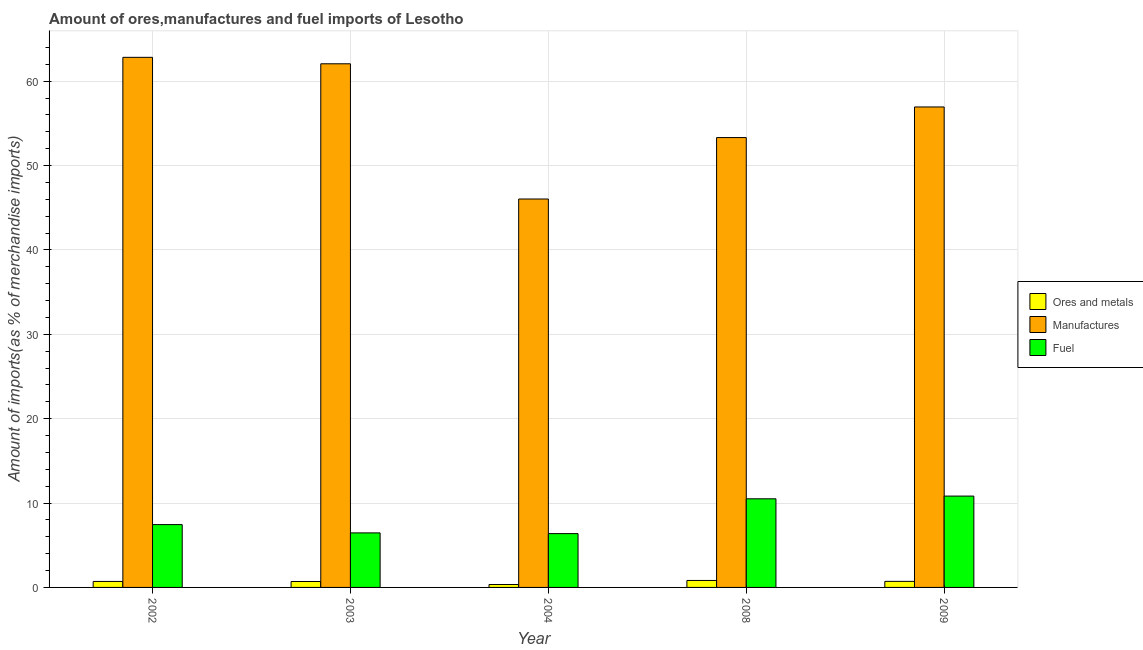How many groups of bars are there?
Provide a succinct answer. 5. Are the number of bars per tick equal to the number of legend labels?
Provide a short and direct response. Yes. Are the number of bars on each tick of the X-axis equal?
Offer a very short reply. Yes. How many bars are there on the 3rd tick from the right?
Provide a succinct answer. 3. What is the percentage of manufactures imports in 2008?
Give a very brief answer. 53.31. Across all years, what is the maximum percentage of manufactures imports?
Your response must be concise. 62.82. Across all years, what is the minimum percentage of ores and metals imports?
Give a very brief answer. 0.34. In which year was the percentage of manufactures imports maximum?
Offer a very short reply. 2002. In which year was the percentage of ores and metals imports minimum?
Provide a short and direct response. 2004. What is the total percentage of fuel imports in the graph?
Provide a short and direct response. 41.61. What is the difference between the percentage of fuel imports in 2003 and that in 2009?
Your answer should be compact. -4.36. What is the difference between the percentage of fuel imports in 2003 and the percentage of ores and metals imports in 2008?
Provide a succinct answer. -4.04. What is the average percentage of manufactures imports per year?
Offer a very short reply. 56.23. In the year 2003, what is the difference between the percentage of manufactures imports and percentage of fuel imports?
Offer a terse response. 0. In how many years, is the percentage of manufactures imports greater than 20 %?
Offer a very short reply. 5. What is the ratio of the percentage of manufactures imports in 2003 to that in 2008?
Offer a terse response. 1.16. Is the percentage of fuel imports in 2004 less than that in 2009?
Your answer should be compact. Yes. Is the difference between the percentage of ores and metals imports in 2002 and 2004 greater than the difference between the percentage of manufactures imports in 2002 and 2004?
Ensure brevity in your answer.  No. What is the difference between the highest and the second highest percentage of ores and metals imports?
Provide a short and direct response. 0.11. What is the difference between the highest and the lowest percentage of manufactures imports?
Your answer should be very brief. 16.79. Is the sum of the percentage of fuel imports in 2003 and 2008 greater than the maximum percentage of ores and metals imports across all years?
Your answer should be compact. Yes. What does the 1st bar from the left in 2008 represents?
Your answer should be compact. Ores and metals. What does the 1st bar from the right in 2004 represents?
Offer a very short reply. Fuel. Is it the case that in every year, the sum of the percentage of ores and metals imports and percentage of manufactures imports is greater than the percentage of fuel imports?
Give a very brief answer. Yes. How many bars are there?
Ensure brevity in your answer.  15. Are all the bars in the graph horizontal?
Give a very brief answer. No. Does the graph contain any zero values?
Give a very brief answer. No. Does the graph contain grids?
Your response must be concise. Yes. What is the title of the graph?
Provide a short and direct response. Amount of ores,manufactures and fuel imports of Lesotho. What is the label or title of the Y-axis?
Offer a terse response. Amount of imports(as % of merchandise imports). What is the Amount of imports(as % of merchandise imports) in Ores and metals in 2002?
Offer a terse response. 0.71. What is the Amount of imports(as % of merchandise imports) in Manufactures in 2002?
Your answer should be compact. 62.82. What is the Amount of imports(as % of merchandise imports) of Fuel in 2002?
Offer a very short reply. 7.45. What is the Amount of imports(as % of merchandise imports) of Ores and metals in 2003?
Keep it short and to the point. 0.7. What is the Amount of imports(as % of merchandise imports) in Manufactures in 2003?
Ensure brevity in your answer.  62.06. What is the Amount of imports(as % of merchandise imports) in Fuel in 2003?
Keep it short and to the point. 6.46. What is the Amount of imports(as % of merchandise imports) of Ores and metals in 2004?
Give a very brief answer. 0.34. What is the Amount of imports(as % of merchandise imports) of Manufactures in 2004?
Provide a short and direct response. 46.03. What is the Amount of imports(as % of merchandise imports) in Fuel in 2004?
Offer a terse response. 6.38. What is the Amount of imports(as % of merchandise imports) in Ores and metals in 2008?
Ensure brevity in your answer.  0.83. What is the Amount of imports(as % of merchandise imports) of Manufactures in 2008?
Keep it short and to the point. 53.31. What is the Amount of imports(as % of merchandise imports) in Fuel in 2008?
Your response must be concise. 10.5. What is the Amount of imports(as % of merchandise imports) of Ores and metals in 2009?
Offer a very short reply. 0.72. What is the Amount of imports(as % of merchandise imports) in Manufactures in 2009?
Give a very brief answer. 56.94. What is the Amount of imports(as % of merchandise imports) of Fuel in 2009?
Provide a succinct answer. 10.83. Across all years, what is the maximum Amount of imports(as % of merchandise imports) of Ores and metals?
Your answer should be very brief. 0.83. Across all years, what is the maximum Amount of imports(as % of merchandise imports) of Manufactures?
Make the answer very short. 62.82. Across all years, what is the maximum Amount of imports(as % of merchandise imports) of Fuel?
Keep it short and to the point. 10.83. Across all years, what is the minimum Amount of imports(as % of merchandise imports) of Ores and metals?
Offer a very short reply. 0.34. Across all years, what is the minimum Amount of imports(as % of merchandise imports) in Manufactures?
Keep it short and to the point. 46.03. Across all years, what is the minimum Amount of imports(as % of merchandise imports) of Fuel?
Your answer should be compact. 6.38. What is the total Amount of imports(as % of merchandise imports) of Ores and metals in the graph?
Provide a short and direct response. 3.3. What is the total Amount of imports(as % of merchandise imports) in Manufactures in the graph?
Your answer should be compact. 281.16. What is the total Amount of imports(as % of merchandise imports) of Fuel in the graph?
Your answer should be compact. 41.61. What is the difference between the Amount of imports(as % of merchandise imports) of Ores and metals in 2002 and that in 2003?
Keep it short and to the point. 0.01. What is the difference between the Amount of imports(as % of merchandise imports) in Manufactures in 2002 and that in 2003?
Your answer should be compact. 0.77. What is the difference between the Amount of imports(as % of merchandise imports) in Fuel in 2002 and that in 2003?
Your answer should be compact. 0.98. What is the difference between the Amount of imports(as % of merchandise imports) in Ores and metals in 2002 and that in 2004?
Keep it short and to the point. 0.36. What is the difference between the Amount of imports(as % of merchandise imports) of Manufactures in 2002 and that in 2004?
Keep it short and to the point. 16.79. What is the difference between the Amount of imports(as % of merchandise imports) of Fuel in 2002 and that in 2004?
Ensure brevity in your answer.  1.07. What is the difference between the Amount of imports(as % of merchandise imports) of Ores and metals in 2002 and that in 2008?
Keep it short and to the point. -0.12. What is the difference between the Amount of imports(as % of merchandise imports) in Manufactures in 2002 and that in 2008?
Your response must be concise. 9.51. What is the difference between the Amount of imports(as % of merchandise imports) in Fuel in 2002 and that in 2008?
Keep it short and to the point. -3.06. What is the difference between the Amount of imports(as % of merchandise imports) of Ores and metals in 2002 and that in 2009?
Your answer should be very brief. -0.01. What is the difference between the Amount of imports(as % of merchandise imports) in Manufactures in 2002 and that in 2009?
Keep it short and to the point. 5.88. What is the difference between the Amount of imports(as % of merchandise imports) of Fuel in 2002 and that in 2009?
Provide a short and direct response. -3.38. What is the difference between the Amount of imports(as % of merchandise imports) of Ores and metals in 2003 and that in 2004?
Give a very brief answer. 0.36. What is the difference between the Amount of imports(as % of merchandise imports) in Manufactures in 2003 and that in 2004?
Your answer should be compact. 16.02. What is the difference between the Amount of imports(as % of merchandise imports) in Fuel in 2003 and that in 2004?
Make the answer very short. 0.09. What is the difference between the Amount of imports(as % of merchandise imports) in Ores and metals in 2003 and that in 2008?
Your answer should be compact. -0.12. What is the difference between the Amount of imports(as % of merchandise imports) in Manufactures in 2003 and that in 2008?
Ensure brevity in your answer.  8.74. What is the difference between the Amount of imports(as % of merchandise imports) of Fuel in 2003 and that in 2008?
Keep it short and to the point. -4.04. What is the difference between the Amount of imports(as % of merchandise imports) of Ores and metals in 2003 and that in 2009?
Your answer should be very brief. -0.02. What is the difference between the Amount of imports(as % of merchandise imports) of Manufactures in 2003 and that in 2009?
Give a very brief answer. 5.12. What is the difference between the Amount of imports(as % of merchandise imports) of Fuel in 2003 and that in 2009?
Provide a short and direct response. -4.36. What is the difference between the Amount of imports(as % of merchandise imports) in Ores and metals in 2004 and that in 2008?
Keep it short and to the point. -0.48. What is the difference between the Amount of imports(as % of merchandise imports) of Manufactures in 2004 and that in 2008?
Ensure brevity in your answer.  -7.28. What is the difference between the Amount of imports(as % of merchandise imports) of Fuel in 2004 and that in 2008?
Provide a succinct answer. -4.13. What is the difference between the Amount of imports(as % of merchandise imports) in Ores and metals in 2004 and that in 2009?
Provide a short and direct response. -0.37. What is the difference between the Amount of imports(as % of merchandise imports) in Manufactures in 2004 and that in 2009?
Provide a short and direct response. -10.91. What is the difference between the Amount of imports(as % of merchandise imports) in Fuel in 2004 and that in 2009?
Your response must be concise. -4.45. What is the difference between the Amount of imports(as % of merchandise imports) of Ores and metals in 2008 and that in 2009?
Make the answer very short. 0.11. What is the difference between the Amount of imports(as % of merchandise imports) of Manufactures in 2008 and that in 2009?
Your answer should be very brief. -3.63. What is the difference between the Amount of imports(as % of merchandise imports) of Fuel in 2008 and that in 2009?
Offer a terse response. -0.32. What is the difference between the Amount of imports(as % of merchandise imports) in Ores and metals in 2002 and the Amount of imports(as % of merchandise imports) in Manufactures in 2003?
Ensure brevity in your answer.  -61.35. What is the difference between the Amount of imports(as % of merchandise imports) of Ores and metals in 2002 and the Amount of imports(as % of merchandise imports) of Fuel in 2003?
Provide a short and direct response. -5.75. What is the difference between the Amount of imports(as % of merchandise imports) in Manufactures in 2002 and the Amount of imports(as % of merchandise imports) in Fuel in 2003?
Offer a terse response. 56.36. What is the difference between the Amount of imports(as % of merchandise imports) in Ores and metals in 2002 and the Amount of imports(as % of merchandise imports) in Manufactures in 2004?
Make the answer very short. -45.32. What is the difference between the Amount of imports(as % of merchandise imports) in Ores and metals in 2002 and the Amount of imports(as % of merchandise imports) in Fuel in 2004?
Ensure brevity in your answer.  -5.67. What is the difference between the Amount of imports(as % of merchandise imports) of Manufactures in 2002 and the Amount of imports(as % of merchandise imports) of Fuel in 2004?
Your response must be concise. 56.45. What is the difference between the Amount of imports(as % of merchandise imports) in Ores and metals in 2002 and the Amount of imports(as % of merchandise imports) in Manufactures in 2008?
Make the answer very short. -52.6. What is the difference between the Amount of imports(as % of merchandise imports) in Ores and metals in 2002 and the Amount of imports(as % of merchandise imports) in Fuel in 2008?
Give a very brief answer. -9.79. What is the difference between the Amount of imports(as % of merchandise imports) in Manufactures in 2002 and the Amount of imports(as % of merchandise imports) in Fuel in 2008?
Keep it short and to the point. 52.32. What is the difference between the Amount of imports(as % of merchandise imports) of Ores and metals in 2002 and the Amount of imports(as % of merchandise imports) of Manufactures in 2009?
Offer a very short reply. -56.23. What is the difference between the Amount of imports(as % of merchandise imports) of Ores and metals in 2002 and the Amount of imports(as % of merchandise imports) of Fuel in 2009?
Make the answer very short. -10.12. What is the difference between the Amount of imports(as % of merchandise imports) of Manufactures in 2002 and the Amount of imports(as % of merchandise imports) of Fuel in 2009?
Ensure brevity in your answer.  52. What is the difference between the Amount of imports(as % of merchandise imports) in Ores and metals in 2003 and the Amount of imports(as % of merchandise imports) in Manufactures in 2004?
Offer a very short reply. -45.33. What is the difference between the Amount of imports(as % of merchandise imports) in Ores and metals in 2003 and the Amount of imports(as % of merchandise imports) in Fuel in 2004?
Your response must be concise. -5.67. What is the difference between the Amount of imports(as % of merchandise imports) of Manufactures in 2003 and the Amount of imports(as % of merchandise imports) of Fuel in 2004?
Offer a very short reply. 55.68. What is the difference between the Amount of imports(as % of merchandise imports) of Ores and metals in 2003 and the Amount of imports(as % of merchandise imports) of Manufactures in 2008?
Offer a very short reply. -52.61. What is the difference between the Amount of imports(as % of merchandise imports) of Manufactures in 2003 and the Amount of imports(as % of merchandise imports) of Fuel in 2008?
Your answer should be compact. 51.55. What is the difference between the Amount of imports(as % of merchandise imports) in Ores and metals in 2003 and the Amount of imports(as % of merchandise imports) in Manufactures in 2009?
Provide a short and direct response. -56.24. What is the difference between the Amount of imports(as % of merchandise imports) in Ores and metals in 2003 and the Amount of imports(as % of merchandise imports) in Fuel in 2009?
Your response must be concise. -10.12. What is the difference between the Amount of imports(as % of merchandise imports) in Manufactures in 2003 and the Amount of imports(as % of merchandise imports) in Fuel in 2009?
Your answer should be compact. 51.23. What is the difference between the Amount of imports(as % of merchandise imports) of Ores and metals in 2004 and the Amount of imports(as % of merchandise imports) of Manufactures in 2008?
Your answer should be very brief. -52.97. What is the difference between the Amount of imports(as % of merchandise imports) of Ores and metals in 2004 and the Amount of imports(as % of merchandise imports) of Fuel in 2008?
Provide a short and direct response. -10.16. What is the difference between the Amount of imports(as % of merchandise imports) of Manufactures in 2004 and the Amount of imports(as % of merchandise imports) of Fuel in 2008?
Give a very brief answer. 35.53. What is the difference between the Amount of imports(as % of merchandise imports) of Ores and metals in 2004 and the Amount of imports(as % of merchandise imports) of Manufactures in 2009?
Your answer should be compact. -56.6. What is the difference between the Amount of imports(as % of merchandise imports) in Ores and metals in 2004 and the Amount of imports(as % of merchandise imports) in Fuel in 2009?
Your answer should be compact. -10.48. What is the difference between the Amount of imports(as % of merchandise imports) in Manufactures in 2004 and the Amount of imports(as % of merchandise imports) in Fuel in 2009?
Provide a succinct answer. 35.21. What is the difference between the Amount of imports(as % of merchandise imports) in Ores and metals in 2008 and the Amount of imports(as % of merchandise imports) in Manufactures in 2009?
Offer a terse response. -56.11. What is the difference between the Amount of imports(as % of merchandise imports) in Ores and metals in 2008 and the Amount of imports(as % of merchandise imports) in Fuel in 2009?
Offer a very short reply. -10. What is the difference between the Amount of imports(as % of merchandise imports) of Manufactures in 2008 and the Amount of imports(as % of merchandise imports) of Fuel in 2009?
Make the answer very short. 42.49. What is the average Amount of imports(as % of merchandise imports) of Ores and metals per year?
Your answer should be very brief. 0.66. What is the average Amount of imports(as % of merchandise imports) of Manufactures per year?
Give a very brief answer. 56.23. What is the average Amount of imports(as % of merchandise imports) in Fuel per year?
Offer a very short reply. 8.32. In the year 2002, what is the difference between the Amount of imports(as % of merchandise imports) in Ores and metals and Amount of imports(as % of merchandise imports) in Manufactures?
Make the answer very short. -62.11. In the year 2002, what is the difference between the Amount of imports(as % of merchandise imports) in Ores and metals and Amount of imports(as % of merchandise imports) in Fuel?
Provide a succinct answer. -6.74. In the year 2002, what is the difference between the Amount of imports(as % of merchandise imports) in Manufactures and Amount of imports(as % of merchandise imports) in Fuel?
Provide a succinct answer. 55.38. In the year 2003, what is the difference between the Amount of imports(as % of merchandise imports) in Ores and metals and Amount of imports(as % of merchandise imports) in Manufactures?
Offer a very short reply. -61.35. In the year 2003, what is the difference between the Amount of imports(as % of merchandise imports) of Ores and metals and Amount of imports(as % of merchandise imports) of Fuel?
Give a very brief answer. -5.76. In the year 2003, what is the difference between the Amount of imports(as % of merchandise imports) of Manufactures and Amount of imports(as % of merchandise imports) of Fuel?
Make the answer very short. 55.59. In the year 2004, what is the difference between the Amount of imports(as % of merchandise imports) of Ores and metals and Amount of imports(as % of merchandise imports) of Manufactures?
Offer a terse response. -45.69. In the year 2004, what is the difference between the Amount of imports(as % of merchandise imports) of Ores and metals and Amount of imports(as % of merchandise imports) of Fuel?
Ensure brevity in your answer.  -6.03. In the year 2004, what is the difference between the Amount of imports(as % of merchandise imports) in Manufactures and Amount of imports(as % of merchandise imports) in Fuel?
Your answer should be compact. 39.66. In the year 2008, what is the difference between the Amount of imports(as % of merchandise imports) of Ores and metals and Amount of imports(as % of merchandise imports) of Manufactures?
Give a very brief answer. -52.49. In the year 2008, what is the difference between the Amount of imports(as % of merchandise imports) in Ores and metals and Amount of imports(as % of merchandise imports) in Fuel?
Provide a succinct answer. -9.68. In the year 2008, what is the difference between the Amount of imports(as % of merchandise imports) of Manufactures and Amount of imports(as % of merchandise imports) of Fuel?
Ensure brevity in your answer.  42.81. In the year 2009, what is the difference between the Amount of imports(as % of merchandise imports) of Ores and metals and Amount of imports(as % of merchandise imports) of Manufactures?
Offer a terse response. -56.22. In the year 2009, what is the difference between the Amount of imports(as % of merchandise imports) in Ores and metals and Amount of imports(as % of merchandise imports) in Fuel?
Your response must be concise. -10.11. In the year 2009, what is the difference between the Amount of imports(as % of merchandise imports) of Manufactures and Amount of imports(as % of merchandise imports) of Fuel?
Your response must be concise. 46.11. What is the ratio of the Amount of imports(as % of merchandise imports) in Ores and metals in 2002 to that in 2003?
Make the answer very short. 1.01. What is the ratio of the Amount of imports(as % of merchandise imports) in Manufactures in 2002 to that in 2003?
Offer a very short reply. 1.01. What is the ratio of the Amount of imports(as % of merchandise imports) in Fuel in 2002 to that in 2003?
Keep it short and to the point. 1.15. What is the ratio of the Amount of imports(as % of merchandise imports) of Ores and metals in 2002 to that in 2004?
Your response must be concise. 2.06. What is the ratio of the Amount of imports(as % of merchandise imports) in Manufactures in 2002 to that in 2004?
Your answer should be compact. 1.36. What is the ratio of the Amount of imports(as % of merchandise imports) of Fuel in 2002 to that in 2004?
Give a very brief answer. 1.17. What is the ratio of the Amount of imports(as % of merchandise imports) of Ores and metals in 2002 to that in 2008?
Ensure brevity in your answer.  0.86. What is the ratio of the Amount of imports(as % of merchandise imports) of Manufactures in 2002 to that in 2008?
Keep it short and to the point. 1.18. What is the ratio of the Amount of imports(as % of merchandise imports) in Fuel in 2002 to that in 2008?
Offer a very short reply. 0.71. What is the ratio of the Amount of imports(as % of merchandise imports) in Ores and metals in 2002 to that in 2009?
Keep it short and to the point. 0.99. What is the ratio of the Amount of imports(as % of merchandise imports) in Manufactures in 2002 to that in 2009?
Offer a very short reply. 1.1. What is the ratio of the Amount of imports(as % of merchandise imports) of Fuel in 2002 to that in 2009?
Your answer should be compact. 0.69. What is the ratio of the Amount of imports(as % of merchandise imports) of Ores and metals in 2003 to that in 2004?
Make the answer very short. 2.05. What is the ratio of the Amount of imports(as % of merchandise imports) of Manufactures in 2003 to that in 2004?
Ensure brevity in your answer.  1.35. What is the ratio of the Amount of imports(as % of merchandise imports) in Fuel in 2003 to that in 2004?
Keep it short and to the point. 1.01. What is the ratio of the Amount of imports(as % of merchandise imports) of Ores and metals in 2003 to that in 2008?
Give a very brief answer. 0.85. What is the ratio of the Amount of imports(as % of merchandise imports) in Manufactures in 2003 to that in 2008?
Give a very brief answer. 1.16. What is the ratio of the Amount of imports(as % of merchandise imports) of Fuel in 2003 to that in 2008?
Provide a short and direct response. 0.62. What is the ratio of the Amount of imports(as % of merchandise imports) of Ores and metals in 2003 to that in 2009?
Provide a succinct answer. 0.98. What is the ratio of the Amount of imports(as % of merchandise imports) of Manufactures in 2003 to that in 2009?
Your response must be concise. 1.09. What is the ratio of the Amount of imports(as % of merchandise imports) of Fuel in 2003 to that in 2009?
Keep it short and to the point. 0.6. What is the ratio of the Amount of imports(as % of merchandise imports) of Ores and metals in 2004 to that in 2008?
Offer a very short reply. 0.42. What is the ratio of the Amount of imports(as % of merchandise imports) of Manufactures in 2004 to that in 2008?
Give a very brief answer. 0.86. What is the ratio of the Amount of imports(as % of merchandise imports) in Fuel in 2004 to that in 2008?
Offer a terse response. 0.61. What is the ratio of the Amount of imports(as % of merchandise imports) in Ores and metals in 2004 to that in 2009?
Give a very brief answer. 0.48. What is the ratio of the Amount of imports(as % of merchandise imports) in Manufactures in 2004 to that in 2009?
Provide a short and direct response. 0.81. What is the ratio of the Amount of imports(as % of merchandise imports) of Fuel in 2004 to that in 2009?
Provide a short and direct response. 0.59. What is the ratio of the Amount of imports(as % of merchandise imports) of Ores and metals in 2008 to that in 2009?
Give a very brief answer. 1.15. What is the ratio of the Amount of imports(as % of merchandise imports) in Manufactures in 2008 to that in 2009?
Your response must be concise. 0.94. What is the ratio of the Amount of imports(as % of merchandise imports) of Fuel in 2008 to that in 2009?
Offer a very short reply. 0.97. What is the difference between the highest and the second highest Amount of imports(as % of merchandise imports) of Ores and metals?
Offer a terse response. 0.11. What is the difference between the highest and the second highest Amount of imports(as % of merchandise imports) in Manufactures?
Provide a succinct answer. 0.77. What is the difference between the highest and the second highest Amount of imports(as % of merchandise imports) of Fuel?
Give a very brief answer. 0.32. What is the difference between the highest and the lowest Amount of imports(as % of merchandise imports) of Ores and metals?
Your response must be concise. 0.48. What is the difference between the highest and the lowest Amount of imports(as % of merchandise imports) of Manufactures?
Keep it short and to the point. 16.79. What is the difference between the highest and the lowest Amount of imports(as % of merchandise imports) in Fuel?
Ensure brevity in your answer.  4.45. 